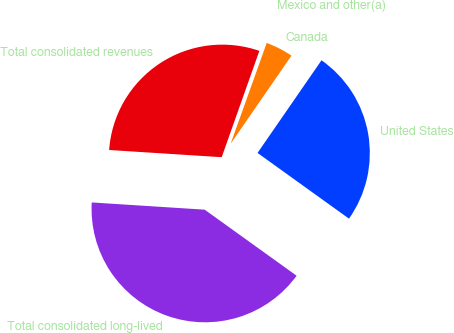Convert chart. <chart><loc_0><loc_0><loc_500><loc_500><pie_chart><fcel>United States<fcel>Canada<fcel>Mexico and other(a)<fcel>Total consolidated revenues<fcel>Total consolidated long-lived<nl><fcel>25.3%<fcel>4.15%<fcel>0.05%<fcel>29.4%<fcel>41.1%<nl></chart> 